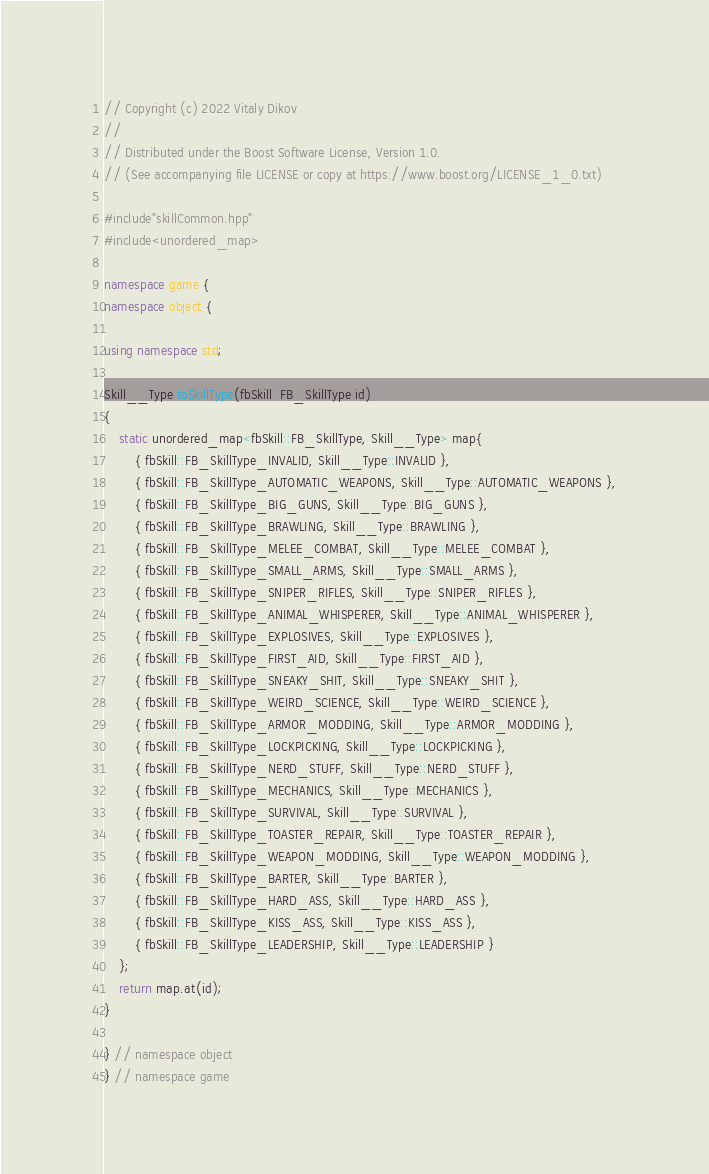<code> <loc_0><loc_0><loc_500><loc_500><_C++_>
// Copyright (c) 2022 Vitaly Dikov
// 
// Distributed under the Boost Software License, Version 1.0.
// (See accompanying file LICENSE or copy at https://www.boost.org/LICENSE_1_0.txt)

#include"skillCommon.hpp"
#include<unordered_map>

namespace game {
namespace object {

using namespace std;

Skill__Type toSkillType(fbSkill::FB_SkillType id)
{
    static unordered_map<fbSkill::FB_SkillType, Skill__Type> map{
        { fbSkill::FB_SkillType_INVALID, Skill__Type::INVALID },
        { fbSkill::FB_SkillType_AUTOMATIC_WEAPONS, Skill__Type::AUTOMATIC_WEAPONS },
        { fbSkill::FB_SkillType_BIG_GUNS, Skill__Type::BIG_GUNS },
        { fbSkill::FB_SkillType_BRAWLING, Skill__Type::BRAWLING },
        { fbSkill::FB_SkillType_MELEE_COMBAT, Skill__Type::MELEE_COMBAT },
        { fbSkill::FB_SkillType_SMALL_ARMS, Skill__Type::SMALL_ARMS },
        { fbSkill::FB_SkillType_SNIPER_RIFLES, Skill__Type::SNIPER_RIFLES },
        { fbSkill::FB_SkillType_ANIMAL_WHISPERER, Skill__Type::ANIMAL_WHISPERER },
        { fbSkill::FB_SkillType_EXPLOSIVES, Skill__Type::EXPLOSIVES },
        { fbSkill::FB_SkillType_FIRST_AID, Skill__Type::FIRST_AID },
        { fbSkill::FB_SkillType_SNEAKY_SHIT, Skill__Type::SNEAKY_SHIT },
        { fbSkill::FB_SkillType_WEIRD_SCIENCE, Skill__Type::WEIRD_SCIENCE },
        { fbSkill::FB_SkillType_ARMOR_MODDING, Skill__Type::ARMOR_MODDING },
        { fbSkill::FB_SkillType_LOCKPICKING, Skill__Type::LOCKPICKING },
        { fbSkill::FB_SkillType_NERD_STUFF, Skill__Type::NERD_STUFF },
        { fbSkill::FB_SkillType_MECHANICS, Skill__Type::MECHANICS },
        { fbSkill::FB_SkillType_SURVIVAL, Skill__Type::SURVIVAL },
        { fbSkill::FB_SkillType_TOASTER_REPAIR, Skill__Type::TOASTER_REPAIR },
        { fbSkill::FB_SkillType_WEAPON_MODDING, Skill__Type::WEAPON_MODDING },
        { fbSkill::FB_SkillType_BARTER, Skill__Type::BARTER },
        { fbSkill::FB_SkillType_HARD_ASS, Skill__Type::HARD_ASS },
        { fbSkill::FB_SkillType_KISS_ASS, Skill__Type::KISS_ASS },
        { fbSkill::FB_SkillType_LEADERSHIP, Skill__Type::LEADERSHIP }
    };
    return map.at(id);
}

} // namespace object
} // namespace game
</code> 